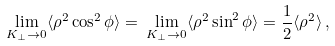Convert formula to latex. <formula><loc_0><loc_0><loc_500><loc_500>\lim _ { K _ { \perp } \to 0 } \langle \rho ^ { 2 } \cos ^ { 2 } \phi \rangle = \, \lim _ { K _ { \perp } \to 0 } \langle \rho ^ { 2 } \sin ^ { 2 } \phi \rangle = { \frac { 1 } { 2 } } \langle \rho ^ { 2 } \rangle \, ,</formula> 